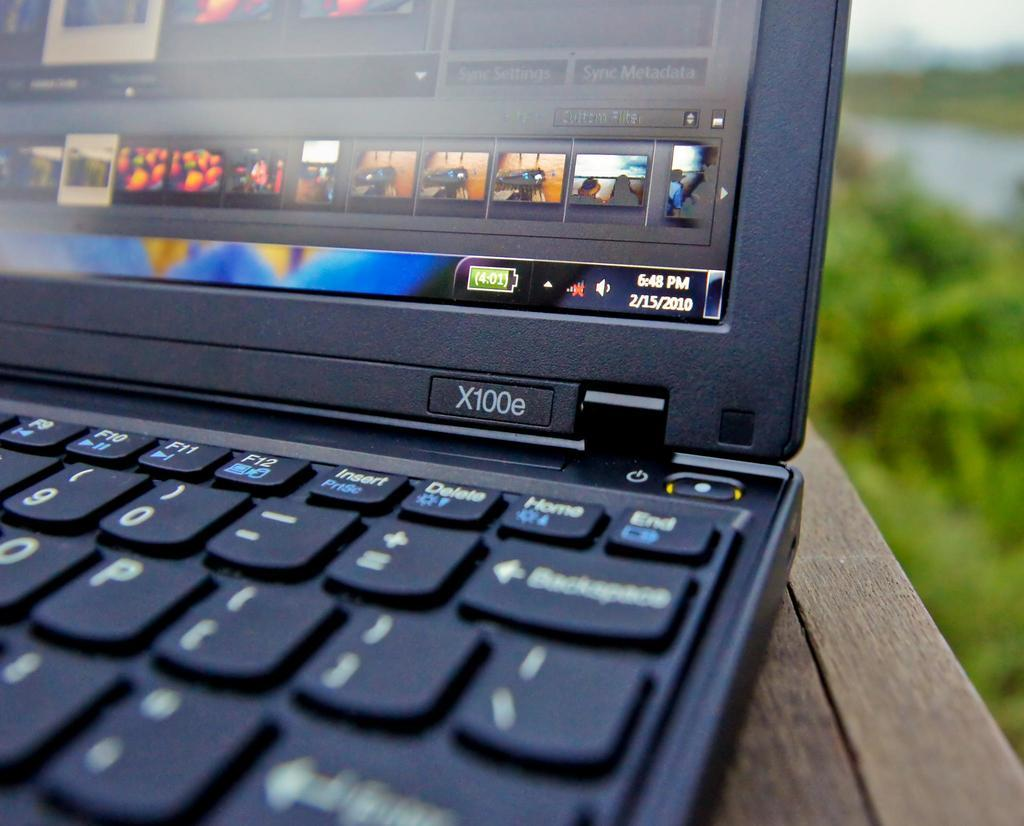What electronic device is visible in the image? There is a laptop in the image. What type of surface is the laptop placed on? There is a wooden surface at the bottom of the image. What can be seen in the background of the image? There are plants in the background of the image. How would you describe the background of the image? The background of the image is blurry. What type of boundary can be seen between the laptop and the wooden surface? There is no boundary visible between the laptop and the wooden surface; they appear to be in direct contact with each other. 